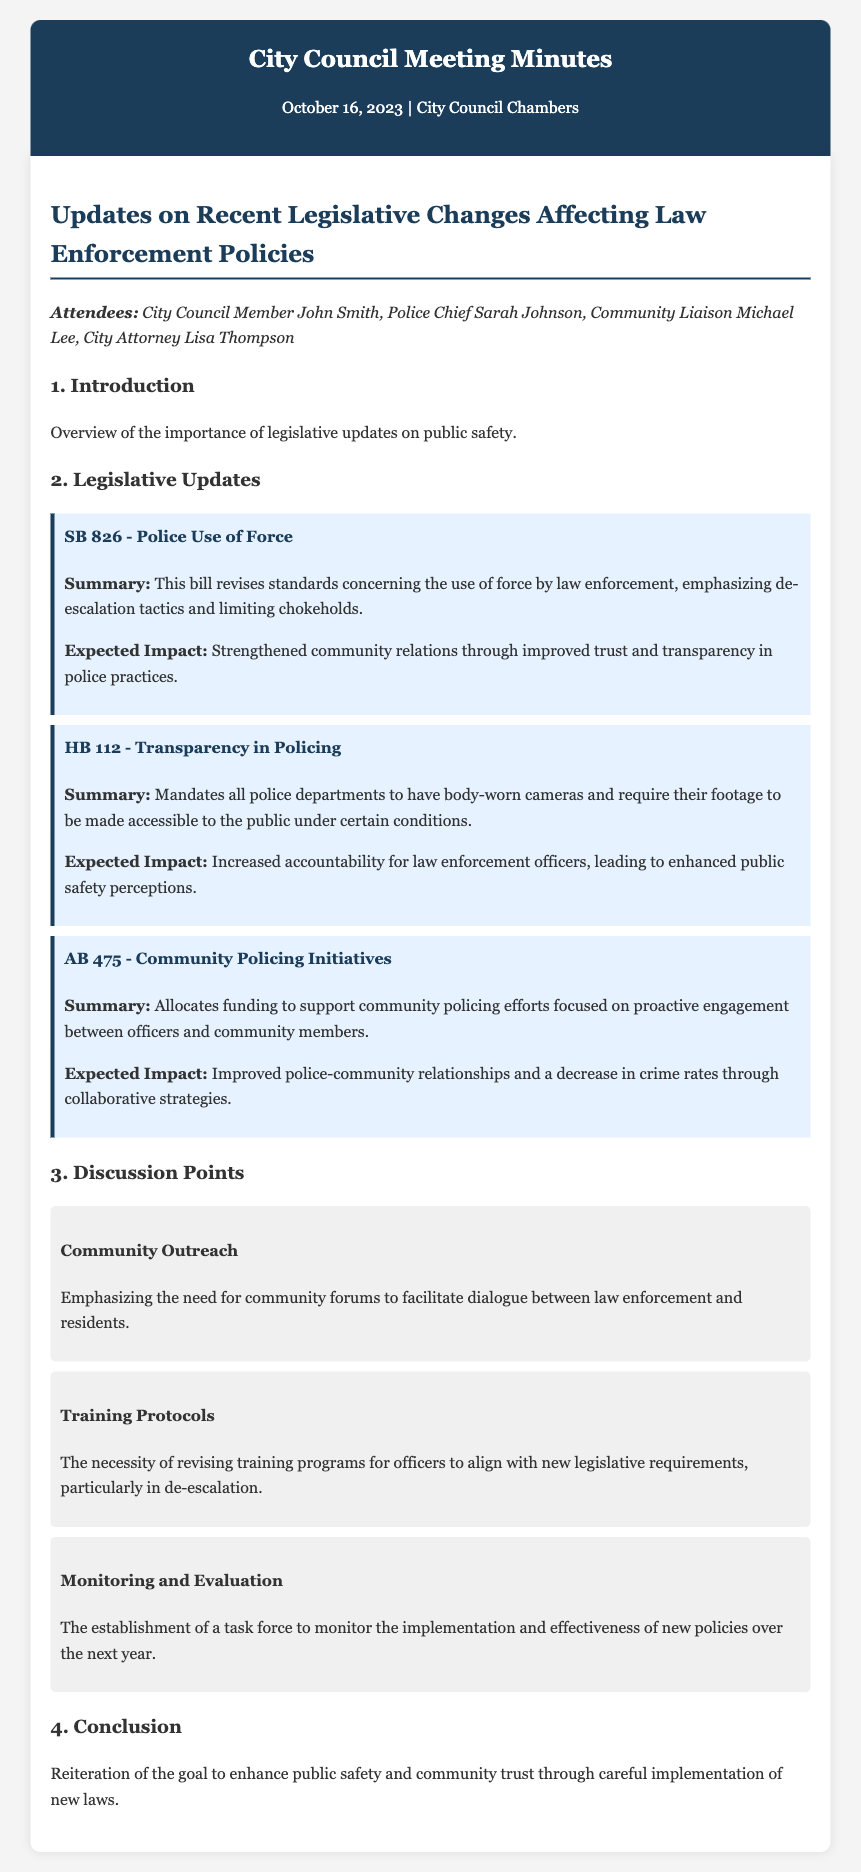What is the title of the first bill discussed? The title of the first bill discussed is SB 826 - Police Use of Force.
Answer: SB 826 - Police Use of Force What is the expected impact of HB 112? The expected impact of HB 112 is increased accountability for law enforcement officers, leading to enhanced public safety perceptions.
Answer: Increased accountability Who is the City Attorney attending the meeting? The City Attorney attending the meeting is Lisa Thompson.
Answer: Lisa Thompson What is the main focus of AB 475? The main focus of AB 475 is to allocate funding to support community policing efforts.
Answer: Community policing efforts What is the date of the City Council Meeting? The date of the City Council Meeting is October 16, 2023.
Answer: October 16, 2023 How many discussion points are listed in the document? There are three discussion points listed in the document.
Answer: Three What is the emphasis of the Community Outreach discussion point? The emphasis of the Community Outreach discussion point is the need for community forums to facilitate dialogue between law enforcement and residents.
Answer: Community forums What is the goal reiterated in the conclusion? The goal reiterated in the conclusion is to enhance public safety and community trust.
Answer: Enhance public safety and community trust 